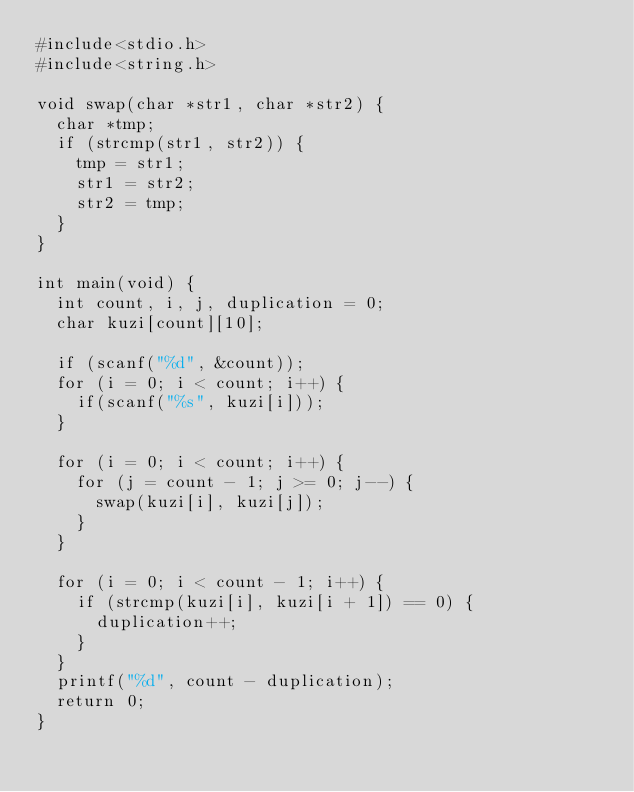Convert code to text. <code><loc_0><loc_0><loc_500><loc_500><_C_>#include<stdio.h>
#include<string.h>

void swap(char *str1, char *str2) {
  char *tmp;
  if (strcmp(str1, str2)) {
    tmp = str1;
    str1 = str2;
    str2 = tmp;
  }
}

int main(void) {
  int count, i, j, duplication = 0;
  char kuzi[count][10];

  if (scanf("%d", &count));
  for (i = 0; i < count; i++) {
    if(scanf("%s", kuzi[i]));
  }

  for (i = 0; i < count; i++) {
    for (j = count - 1; j >= 0; j--) {
      swap(kuzi[i], kuzi[j]);
    }
  }

  for (i = 0; i < count - 1; i++) {
    if (strcmp(kuzi[i], kuzi[i + 1]) == 0) {
      duplication++;
    } 
  }
  printf("%d", count - duplication);
  return 0;
}</code> 